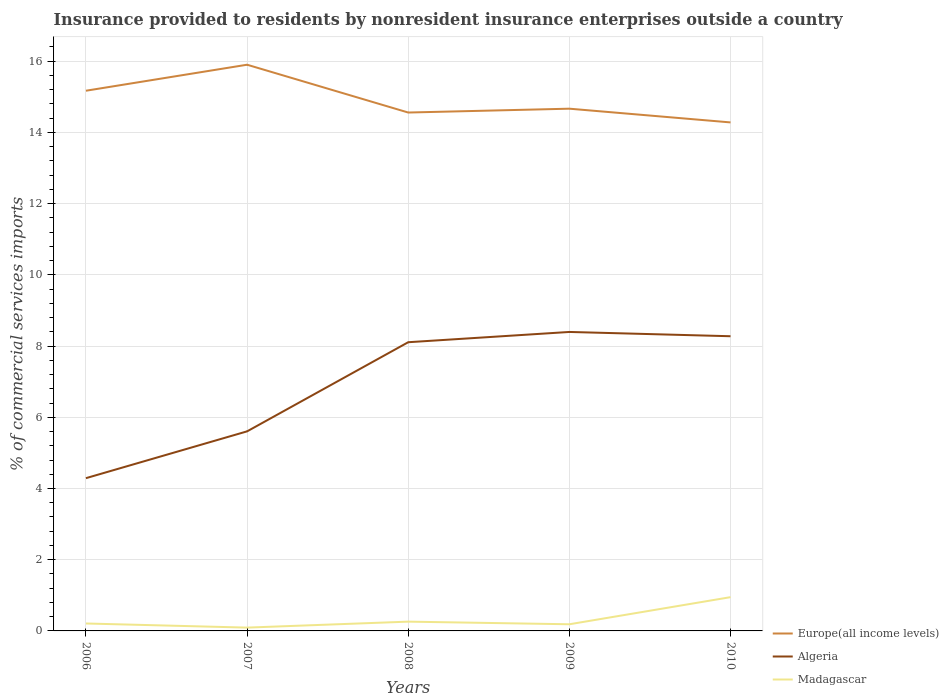Does the line corresponding to Algeria intersect with the line corresponding to Europe(all income levels)?
Your answer should be compact. No. Across all years, what is the maximum Insurance provided to residents in Madagascar?
Your answer should be very brief. 0.09. In which year was the Insurance provided to residents in Madagascar maximum?
Offer a terse response. 2007. What is the total Insurance provided to residents in Algeria in the graph?
Offer a very short reply. -3.99. What is the difference between the highest and the second highest Insurance provided to residents in Madagascar?
Your answer should be compact. 0.86. What is the difference between the highest and the lowest Insurance provided to residents in Algeria?
Ensure brevity in your answer.  3. Is the Insurance provided to residents in Algeria strictly greater than the Insurance provided to residents in Europe(all income levels) over the years?
Your response must be concise. Yes. How many years are there in the graph?
Provide a short and direct response. 5. Does the graph contain any zero values?
Provide a short and direct response. No. What is the title of the graph?
Your response must be concise. Insurance provided to residents by nonresident insurance enterprises outside a country. What is the label or title of the Y-axis?
Offer a terse response. % of commercial services imports. What is the % of commercial services imports of Europe(all income levels) in 2006?
Offer a very short reply. 15.17. What is the % of commercial services imports of Algeria in 2006?
Ensure brevity in your answer.  4.29. What is the % of commercial services imports of Madagascar in 2006?
Your answer should be compact. 0.21. What is the % of commercial services imports of Europe(all income levels) in 2007?
Offer a terse response. 15.9. What is the % of commercial services imports of Algeria in 2007?
Your answer should be very brief. 5.6. What is the % of commercial services imports of Madagascar in 2007?
Provide a succinct answer. 0.09. What is the % of commercial services imports of Europe(all income levels) in 2008?
Keep it short and to the point. 14.56. What is the % of commercial services imports in Algeria in 2008?
Your answer should be very brief. 8.11. What is the % of commercial services imports in Madagascar in 2008?
Provide a succinct answer. 0.26. What is the % of commercial services imports of Europe(all income levels) in 2009?
Ensure brevity in your answer.  14.67. What is the % of commercial services imports of Algeria in 2009?
Give a very brief answer. 8.4. What is the % of commercial services imports in Madagascar in 2009?
Your response must be concise. 0.19. What is the % of commercial services imports of Europe(all income levels) in 2010?
Keep it short and to the point. 14.28. What is the % of commercial services imports in Algeria in 2010?
Your answer should be very brief. 8.28. What is the % of commercial services imports in Madagascar in 2010?
Your response must be concise. 0.95. Across all years, what is the maximum % of commercial services imports in Europe(all income levels)?
Keep it short and to the point. 15.9. Across all years, what is the maximum % of commercial services imports of Algeria?
Your response must be concise. 8.4. Across all years, what is the maximum % of commercial services imports in Madagascar?
Your answer should be compact. 0.95. Across all years, what is the minimum % of commercial services imports in Europe(all income levels)?
Your response must be concise. 14.28. Across all years, what is the minimum % of commercial services imports in Algeria?
Offer a very short reply. 4.29. Across all years, what is the minimum % of commercial services imports in Madagascar?
Provide a succinct answer. 0.09. What is the total % of commercial services imports in Europe(all income levels) in the graph?
Offer a terse response. 74.58. What is the total % of commercial services imports in Algeria in the graph?
Offer a terse response. 34.68. What is the total % of commercial services imports of Madagascar in the graph?
Provide a short and direct response. 1.7. What is the difference between the % of commercial services imports of Europe(all income levels) in 2006 and that in 2007?
Keep it short and to the point. -0.73. What is the difference between the % of commercial services imports in Algeria in 2006 and that in 2007?
Give a very brief answer. -1.31. What is the difference between the % of commercial services imports of Madagascar in 2006 and that in 2007?
Provide a succinct answer. 0.12. What is the difference between the % of commercial services imports in Europe(all income levels) in 2006 and that in 2008?
Keep it short and to the point. 0.61. What is the difference between the % of commercial services imports of Algeria in 2006 and that in 2008?
Offer a terse response. -3.82. What is the difference between the % of commercial services imports in Madagascar in 2006 and that in 2008?
Provide a succinct answer. -0.05. What is the difference between the % of commercial services imports of Europe(all income levels) in 2006 and that in 2009?
Make the answer very short. 0.5. What is the difference between the % of commercial services imports in Algeria in 2006 and that in 2009?
Offer a very short reply. -4.11. What is the difference between the % of commercial services imports in Madagascar in 2006 and that in 2009?
Offer a terse response. 0.02. What is the difference between the % of commercial services imports of Europe(all income levels) in 2006 and that in 2010?
Offer a very short reply. 0.89. What is the difference between the % of commercial services imports of Algeria in 2006 and that in 2010?
Offer a terse response. -3.99. What is the difference between the % of commercial services imports in Madagascar in 2006 and that in 2010?
Ensure brevity in your answer.  -0.74. What is the difference between the % of commercial services imports of Europe(all income levels) in 2007 and that in 2008?
Ensure brevity in your answer.  1.34. What is the difference between the % of commercial services imports of Algeria in 2007 and that in 2008?
Offer a terse response. -2.5. What is the difference between the % of commercial services imports in Madagascar in 2007 and that in 2008?
Your response must be concise. -0.17. What is the difference between the % of commercial services imports of Europe(all income levels) in 2007 and that in 2009?
Your answer should be very brief. 1.23. What is the difference between the % of commercial services imports in Algeria in 2007 and that in 2009?
Provide a short and direct response. -2.79. What is the difference between the % of commercial services imports of Madagascar in 2007 and that in 2009?
Your response must be concise. -0.09. What is the difference between the % of commercial services imports in Europe(all income levels) in 2007 and that in 2010?
Provide a short and direct response. 1.62. What is the difference between the % of commercial services imports in Algeria in 2007 and that in 2010?
Provide a short and direct response. -2.67. What is the difference between the % of commercial services imports of Madagascar in 2007 and that in 2010?
Keep it short and to the point. -0.86. What is the difference between the % of commercial services imports of Europe(all income levels) in 2008 and that in 2009?
Ensure brevity in your answer.  -0.11. What is the difference between the % of commercial services imports of Algeria in 2008 and that in 2009?
Provide a short and direct response. -0.29. What is the difference between the % of commercial services imports in Madagascar in 2008 and that in 2009?
Provide a succinct answer. 0.07. What is the difference between the % of commercial services imports in Europe(all income levels) in 2008 and that in 2010?
Offer a terse response. 0.28. What is the difference between the % of commercial services imports of Algeria in 2008 and that in 2010?
Your response must be concise. -0.17. What is the difference between the % of commercial services imports of Madagascar in 2008 and that in 2010?
Provide a succinct answer. -0.69. What is the difference between the % of commercial services imports in Europe(all income levels) in 2009 and that in 2010?
Keep it short and to the point. 0.39. What is the difference between the % of commercial services imports of Algeria in 2009 and that in 2010?
Provide a short and direct response. 0.12. What is the difference between the % of commercial services imports of Madagascar in 2009 and that in 2010?
Give a very brief answer. -0.76. What is the difference between the % of commercial services imports of Europe(all income levels) in 2006 and the % of commercial services imports of Algeria in 2007?
Keep it short and to the point. 9.57. What is the difference between the % of commercial services imports of Europe(all income levels) in 2006 and the % of commercial services imports of Madagascar in 2007?
Your answer should be very brief. 15.08. What is the difference between the % of commercial services imports in Algeria in 2006 and the % of commercial services imports in Madagascar in 2007?
Give a very brief answer. 4.2. What is the difference between the % of commercial services imports in Europe(all income levels) in 2006 and the % of commercial services imports in Algeria in 2008?
Offer a terse response. 7.06. What is the difference between the % of commercial services imports in Europe(all income levels) in 2006 and the % of commercial services imports in Madagascar in 2008?
Give a very brief answer. 14.91. What is the difference between the % of commercial services imports of Algeria in 2006 and the % of commercial services imports of Madagascar in 2008?
Give a very brief answer. 4.03. What is the difference between the % of commercial services imports of Europe(all income levels) in 2006 and the % of commercial services imports of Algeria in 2009?
Ensure brevity in your answer.  6.78. What is the difference between the % of commercial services imports in Europe(all income levels) in 2006 and the % of commercial services imports in Madagascar in 2009?
Make the answer very short. 14.98. What is the difference between the % of commercial services imports in Algeria in 2006 and the % of commercial services imports in Madagascar in 2009?
Provide a short and direct response. 4.1. What is the difference between the % of commercial services imports of Europe(all income levels) in 2006 and the % of commercial services imports of Algeria in 2010?
Offer a terse response. 6.9. What is the difference between the % of commercial services imports in Europe(all income levels) in 2006 and the % of commercial services imports in Madagascar in 2010?
Your response must be concise. 14.22. What is the difference between the % of commercial services imports in Algeria in 2006 and the % of commercial services imports in Madagascar in 2010?
Offer a terse response. 3.34. What is the difference between the % of commercial services imports in Europe(all income levels) in 2007 and the % of commercial services imports in Algeria in 2008?
Your response must be concise. 7.79. What is the difference between the % of commercial services imports of Europe(all income levels) in 2007 and the % of commercial services imports of Madagascar in 2008?
Your response must be concise. 15.64. What is the difference between the % of commercial services imports in Algeria in 2007 and the % of commercial services imports in Madagascar in 2008?
Offer a terse response. 5.34. What is the difference between the % of commercial services imports in Europe(all income levels) in 2007 and the % of commercial services imports in Algeria in 2009?
Your answer should be very brief. 7.51. What is the difference between the % of commercial services imports of Europe(all income levels) in 2007 and the % of commercial services imports of Madagascar in 2009?
Your answer should be very brief. 15.71. What is the difference between the % of commercial services imports in Algeria in 2007 and the % of commercial services imports in Madagascar in 2009?
Your response must be concise. 5.42. What is the difference between the % of commercial services imports of Europe(all income levels) in 2007 and the % of commercial services imports of Algeria in 2010?
Provide a short and direct response. 7.63. What is the difference between the % of commercial services imports of Europe(all income levels) in 2007 and the % of commercial services imports of Madagascar in 2010?
Provide a short and direct response. 14.95. What is the difference between the % of commercial services imports in Algeria in 2007 and the % of commercial services imports in Madagascar in 2010?
Give a very brief answer. 4.66. What is the difference between the % of commercial services imports in Europe(all income levels) in 2008 and the % of commercial services imports in Algeria in 2009?
Provide a succinct answer. 6.16. What is the difference between the % of commercial services imports of Europe(all income levels) in 2008 and the % of commercial services imports of Madagascar in 2009?
Keep it short and to the point. 14.37. What is the difference between the % of commercial services imports in Algeria in 2008 and the % of commercial services imports in Madagascar in 2009?
Your response must be concise. 7.92. What is the difference between the % of commercial services imports in Europe(all income levels) in 2008 and the % of commercial services imports in Algeria in 2010?
Provide a short and direct response. 6.28. What is the difference between the % of commercial services imports in Europe(all income levels) in 2008 and the % of commercial services imports in Madagascar in 2010?
Offer a very short reply. 13.61. What is the difference between the % of commercial services imports of Algeria in 2008 and the % of commercial services imports of Madagascar in 2010?
Ensure brevity in your answer.  7.16. What is the difference between the % of commercial services imports of Europe(all income levels) in 2009 and the % of commercial services imports of Algeria in 2010?
Offer a very short reply. 6.39. What is the difference between the % of commercial services imports of Europe(all income levels) in 2009 and the % of commercial services imports of Madagascar in 2010?
Make the answer very short. 13.72. What is the difference between the % of commercial services imports of Algeria in 2009 and the % of commercial services imports of Madagascar in 2010?
Your answer should be very brief. 7.45. What is the average % of commercial services imports in Europe(all income levels) per year?
Keep it short and to the point. 14.92. What is the average % of commercial services imports in Algeria per year?
Provide a short and direct response. 6.94. What is the average % of commercial services imports in Madagascar per year?
Give a very brief answer. 0.34. In the year 2006, what is the difference between the % of commercial services imports in Europe(all income levels) and % of commercial services imports in Algeria?
Provide a short and direct response. 10.88. In the year 2006, what is the difference between the % of commercial services imports of Europe(all income levels) and % of commercial services imports of Madagascar?
Provide a short and direct response. 14.96. In the year 2006, what is the difference between the % of commercial services imports in Algeria and % of commercial services imports in Madagascar?
Your answer should be very brief. 4.08. In the year 2007, what is the difference between the % of commercial services imports in Europe(all income levels) and % of commercial services imports in Algeria?
Your answer should be compact. 10.3. In the year 2007, what is the difference between the % of commercial services imports of Europe(all income levels) and % of commercial services imports of Madagascar?
Ensure brevity in your answer.  15.81. In the year 2007, what is the difference between the % of commercial services imports of Algeria and % of commercial services imports of Madagascar?
Ensure brevity in your answer.  5.51. In the year 2008, what is the difference between the % of commercial services imports of Europe(all income levels) and % of commercial services imports of Algeria?
Your response must be concise. 6.45. In the year 2008, what is the difference between the % of commercial services imports in Europe(all income levels) and % of commercial services imports in Madagascar?
Give a very brief answer. 14.3. In the year 2008, what is the difference between the % of commercial services imports in Algeria and % of commercial services imports in Madagascar?
Make the answer very short. 7.85. In the year 2009, what is the difference between the % of commercial services imports in Europe(all income levels) and % of commercial services imports in Algeria?
Provide a short and direct response. 6.27. In the year 2009, what is the difference between the % of commercial services imports in Europe(all income levels) and % of commercial services imports in Madagascar?
Give a very brief answer. 14.48. In the year 2009, what is the difference between the % of commercial services imports of Algeria and % of commercial services imports of Madagascar?
Make the answer very short. 8.21. In the year 2010, what is the difference between the % of commercial services imports of Europe(all income levels) and % of commercial services imports of Algeria?
Make the answer very short. 6.01. In the year 2010, what is the difference between the % of commercial services imports of Europe(all income levels) and % of commercial services imports of Madagascar?
Keep it short and to the point. 13.33. In the year 2010, what is the difference between the % of commercial services imports in Algeria and % of commercial services imports in Madagascar?
Make the answer very short. 7.33. What is the ratio of the % of commercial services imports of Europe(all income levels) in 2006 to that in 2007?
Offer a terse response. 0.95. What is the ratio of the % of commercial services imports in Algeria in 2006 to that in 2007?
Provide a short and direct response. 0.77. What is the ratio of the % of commercial services imports of Madagascar in 2006 to that in 2007?
Your answer should be compact. 2.24. What is the ratio of the % of commercial services imports of Europe(all income levels) in 2006 to that in 2008?
Offer a terse response. 1.04. What is the ratio of the % of commercial services imports in Algeria in 2006 to that in 2008?
Give a very brief answer. 0.53. What is the ratio of the % of commercial services imports of Madagascar in 2006 to that in 2008?
Offer a terse response. 0.8. What is the ratio of the % of commercial services imports of Europe(all income levels) in 2006 to that in 2009?
Make the answer very short. 1.03. What is the ratio of the % of commercial services imports in Algeria in 2006 to that in 2009?
Make the answer very short. 0.51. What is the ratio of the % of commercial services imports of Madagascar in 2006 to that in 2009?
Make the answer very short. 1.12. What is the ratio of the % of commercial services imports in Europe(all income levels) in 2006 to that in 2010?
Offer a terse response. 1.06. What is the ratio of the % of commercial services imports of Algeria in 2006 to that in 2010?
Give a very brief answer. 0.52. What is the ratio of the % of commercial services imports in Madagascar in 2006 to that in 2010?
Your response must be concise. 0.22. What is the ratio of the % of commercial services imports of Europe(all income levels) in 2007 to that in 2008?
Make the answer very short. 1.09. What is the ratio of the % of commercial services imports of Algeria in 2007 to that in 2008?
Give a very brief answer. 0.69. What is the ratio of the % of commercial services imports of Madagascar in 2007 to that in 2008?
Provide a succinct answer. 0.36. What is the ratio of the % of commercial services imports in Europe(all income levels) in 2007 to that in 2009?
Give a very brief answer. 1.08. What is the ratio of the % of commercial services imports in Algeria in 2007 to that in 2009?
Your answer should be very brief. 0.67. What is the ratio of the % of commercial services imports of Madagascar in 2007 to that in 2009?
Your answer should be very brief. 0.5. What is the ratio of the % of commercial services imports of Europe(all income levels) in 2007 to that in 2010?
Your answer should be very brief. 1.11. What is the ratio of the % of commercial services imports in Algeria in 2007 to that in 2010?
Offer a very short reply. 0.68. What is the ratio of the % of commercial services imports of Madagascar in 2007 to that in 2010?
Keep it short and to the point. 0.1. What is the ratio of the % of commercial services imports of Europe(all income levels) in 2008 to that in 2009?
Provide a succinct answer. 0.99. What is the ratio of the % of commercial services imports in Algeria in 2008 to that in 2009?
Give a very brief answer. 0.97. What is the ratio of the % of commercial services imports of Madagascar in 2008 to that in 2009?
Offer a very short reply. 1.39. What is the ratio of the % of commercial services imports of Europe(all income levels) in 2008 to that in 2010?
Offer a very short reply. 1.02. What is the ratio of the % of commercial services imports in Algeria in 2008 to that in 2010?
Keep it short and to the point. 0.98. What is the ratio of the % of commercial services imports in Madagascar in 2008 to that in 2010?
Offer a very short reply. 0.27. What is the ratio of the % of commercial services imports in Europe(all income levels) in 2009 to that in 2010?
Give a very brief answer. 1.03. What is the ratio of the % of commercial services imports in Algeria in 2009 to that in 2010?
Keep it short and to the point. 1.01. What is the ratio of the % of commercial services imports in Madagascar in 2009 to that in 2010?
Give a very brief answer. 0.2. What is the difference between the highest and the second highest % of commercial services imports of Europe(all income levels)?
Your answer should be very brief. 0.73. What is the difference between the highest and the second highest % of commercial services imports of Algeria?
Ensure brevity in your answer.  0.12. What is the difference between the highest and the second highest % of commercial services imports in Madagascar?
Ensure brevity in your answer.  0.69. What is the difference between the highest and the lowest % of commercial services imports in Europe(all income levels)?
Give a very brief answer. 1.62. What is the difference between the highest and the lowest % of commercial services imports of Algeria?
Give a very brief answer. 4.11. What is the difference between the highest and the lowest % of commercial services imports of Madagascar?
Your answer should be compact. 0.86. 